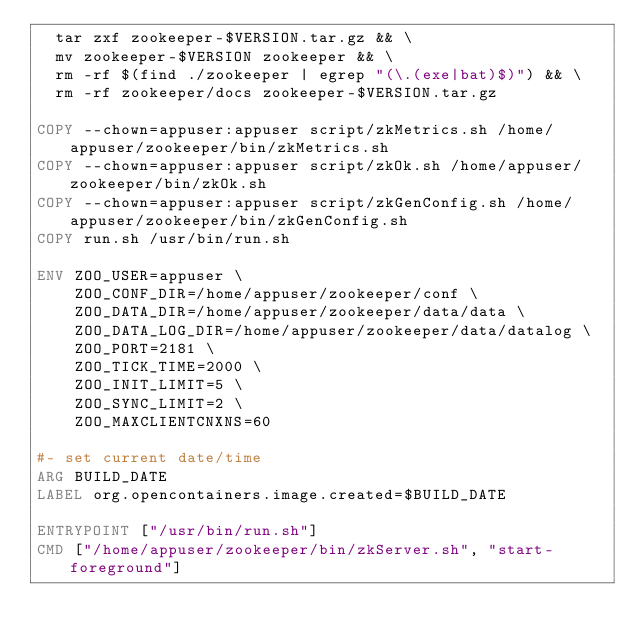<code> <loc_0><loc_0><loc_500><loc_500><_Dockerfile_>  tar zxf zookeeper-$VERSION.tar.gz && \
  mv zookeeper-$VERSION zookeeper && \
  rm -rf $(find ./zookeeper | egrep "(\.(exe|bat)$)") && \
  rm -rf zookeeper/docs zookeeper-$VERSION.tar.gz

COPY --chown=appuser:appuser script/zkMetrics.sh /home/appuser/zookeeper/bin/zkMetrics.sh
COPY --chown=appuser:appuser script/zkOk.sh /home/appuser/zookeeper/bin/zkOk.sh
COPY --chown=appuser:appuser script/zkGenConfig.sh /home/appuser/zookeeper/bin/zkGenConfig.sh
COPY run.sh /usr/bin/run.sh

ENV ZOO_USER=appuser \
    ZOO_CONF_DIR=/home/appuser/zookeeper/conf \
    ZOO_DATA_DIR=/home/appuser/zookeeper/data/data \
    ZOO_DATA_LOG_DIR=/home/appuser/zookeeper/data/datalog \
    ZOO_PORT=2181 \
    ZOO_TICK_TIME=2000 \
    ZOO_INIT_LIMIT=5 \
    ZOO_SYNC_LIMIT=2 \
    ZOO_MAXCLIENTCNXNS=60

#- set current date/time
ARG BUILD_DATE
LABEL org.opencontainers.image.created=$BUILD_DATE 

ENTRYPOINT ["/usr/bin/run.sh"]
CMD ["/home/appuser/zookeeper/bin/zkServer.sh", "start-foreground"]

</code> 